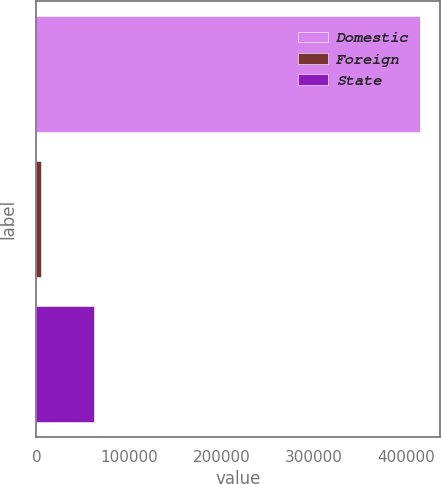Convert chart. <chart><loc_0><loc_0><loc_500><loc_500><bar_chart><fcel>Domestic<fcel>Foreign<fcel>State<nl><fcel>415144<fcel>4495<fcel>62630<nl></chart> 